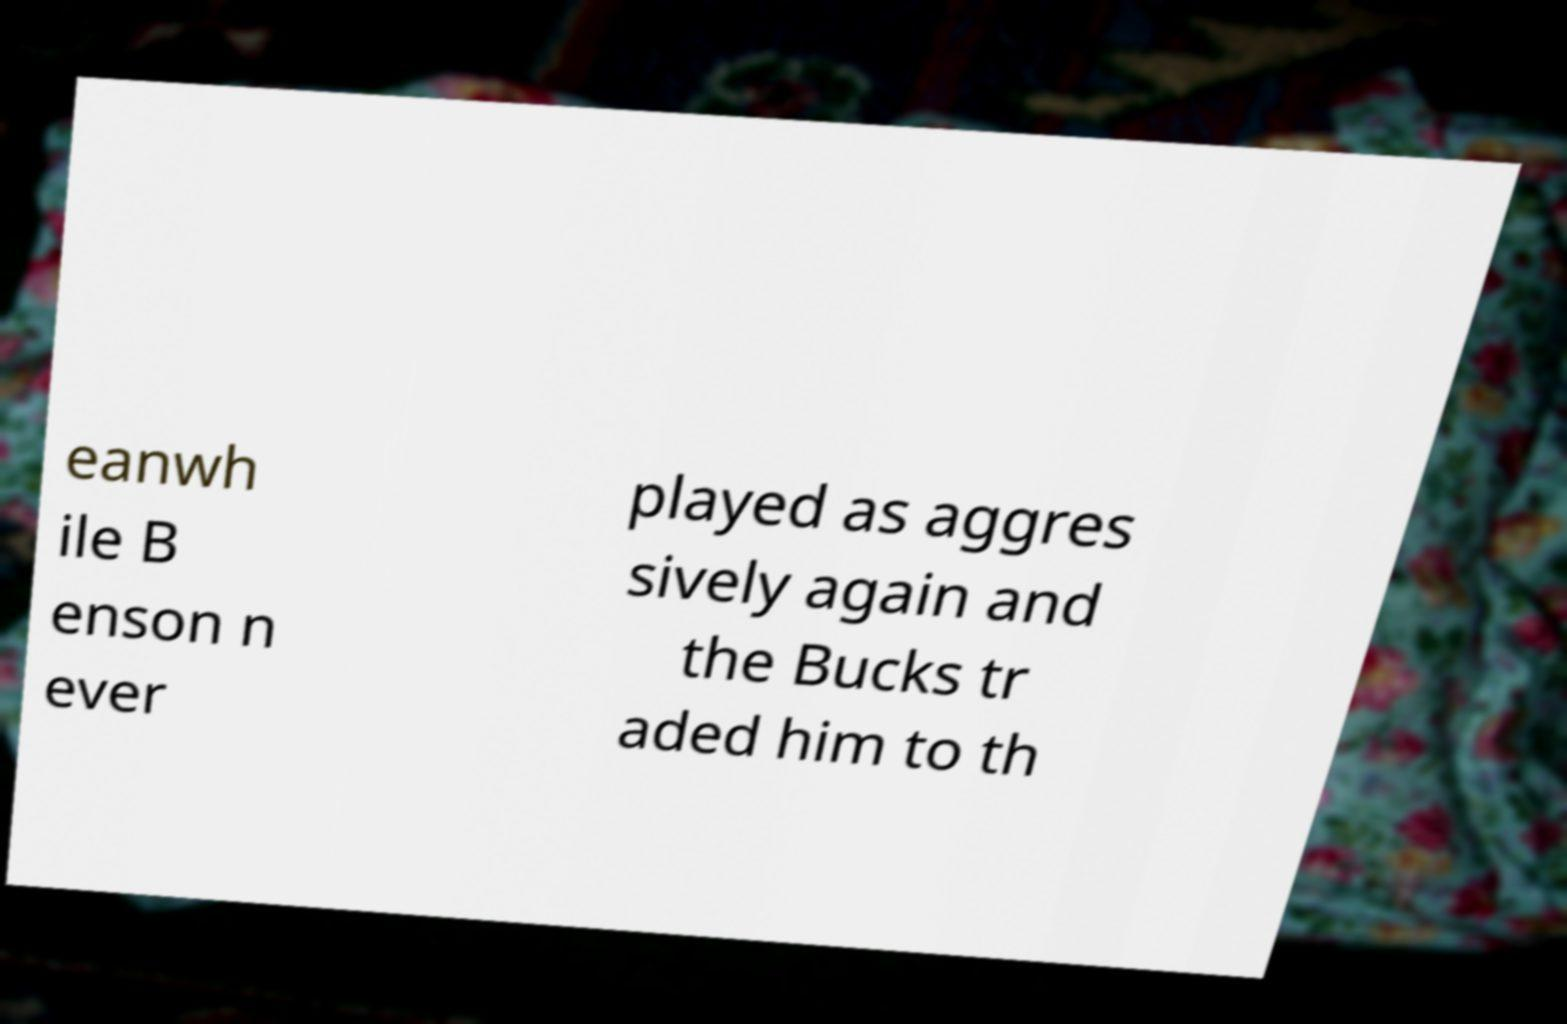Can you read and provide the text displayed in the image?This photo seems to have some interesting text. Can you extract and type it out for me? eanwh ile B enson n ever played as aggres sively again and the Bucks tr aded him to th 